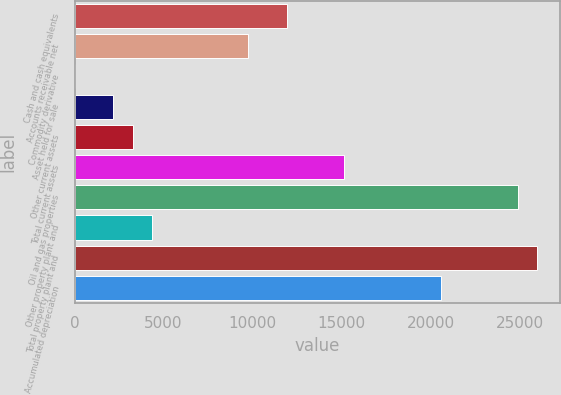<chart> <loc_0><loc_0><loc_500><loc_500><bar_chart><fcel>Cash and cash equivalents<fcel>Accounts receivable net<fcel>Commodity derivative<fcel>Asset held for sale<fcel>Other current assets<fcel>Total current assets<fcel>Oil and gas properties<fcel>Other property plant and<fcel>Total property plant and<fcel>Accumulated depreciation<nl><fcel>11912.6<fcel>9749.4<fcel>15<fcel>2178.2<fcel>3259.8<fcel>15157.4<fcel>24891.8<fcel>4341.4<fcel>25973.4<fcel>20565.4<nl></chart> 